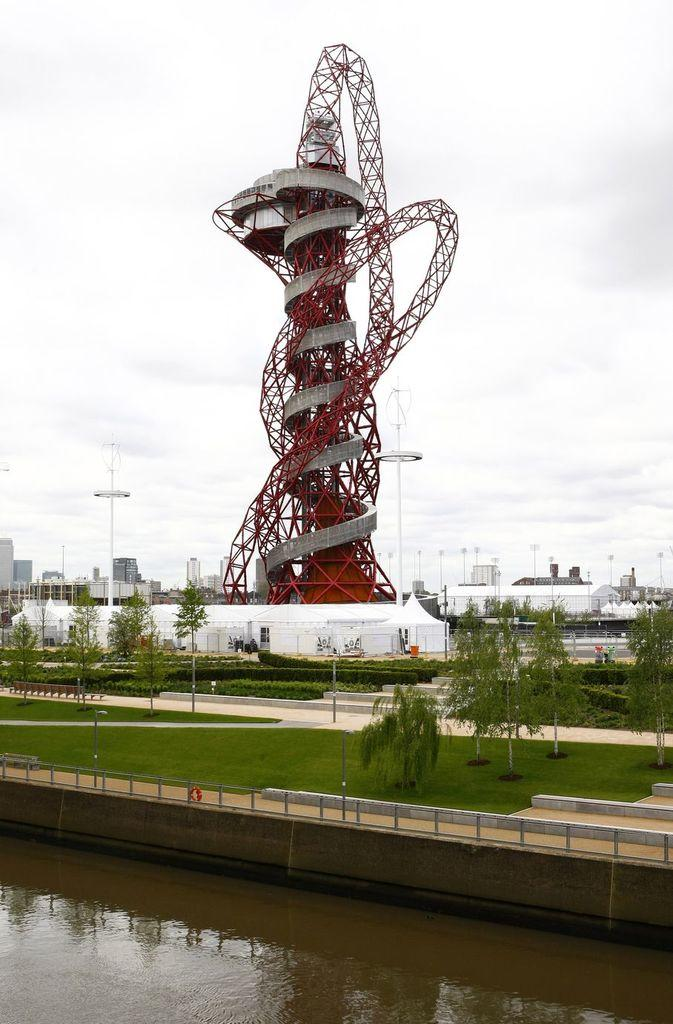What type of structures can be seen in the image? There are buildings and a tower in the image. What natural elements are present in the image? There are trees and grass in the image. What type of surface is visible in the image? There is ground visible in the image. What man-made objects can be seen in the image? There are poles and a wall in the image. What type of barrier is present in the image? There is a fence in the image. What can be seen in the background of the image? The sky is visible in the image. Is there any water visible in the image? Yes, there is water visible in the image. What type of apparel is the tower wearing in the image? There is no apparel present in the image, as the tower is an inanimate object. How many thumbs can be seen supporting the buildings in the image? There are no thumbs visible in the image, as the buildings are supported by their foundations and not by human hands. 